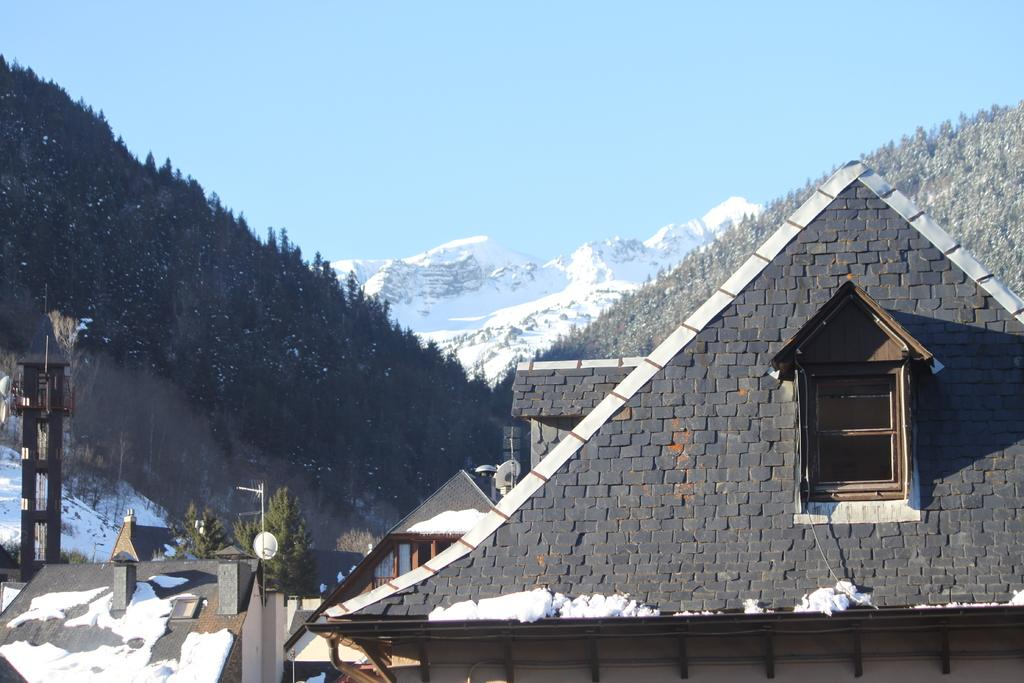What type of structures are present in the image? There are houses in the image. What other natural elements can be seen in the image? There are trees and snow-covered mountains in the image. What is visible in the background of the image? The sky is visible in the background of the image. How many clams can be seen on the boat in the image? There is no boat or clams present in the image. 